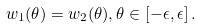<formula> <loc_0><loc_0><loc_500><loc_500>w _ { 1 } ( \theta ) = w _ { 2 } ( \theta ) , \theta \in [ - \epsilon , \epsilon ] \, .</formula> 